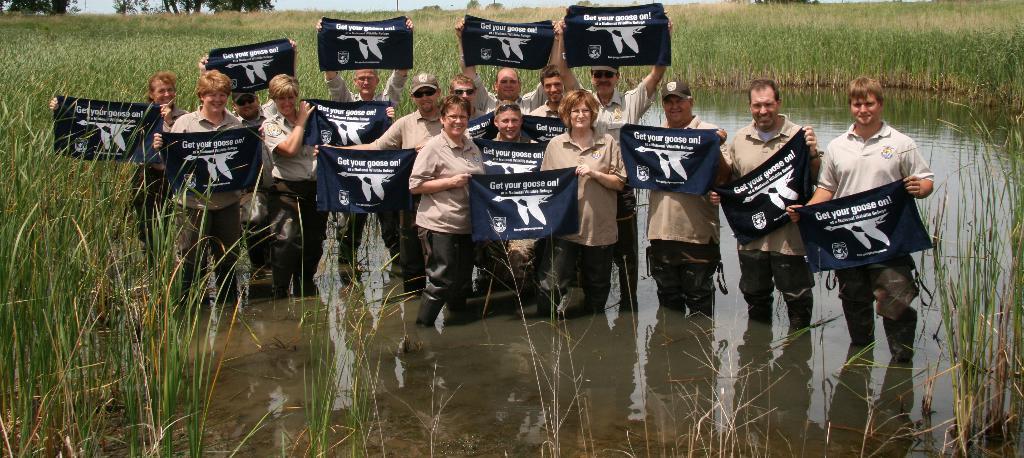Please provide a concise description of this image. In this image there are people standing in the water. They are holding the banners which are having some text. There is grass on the land having trees. Top of the image there is sky. 